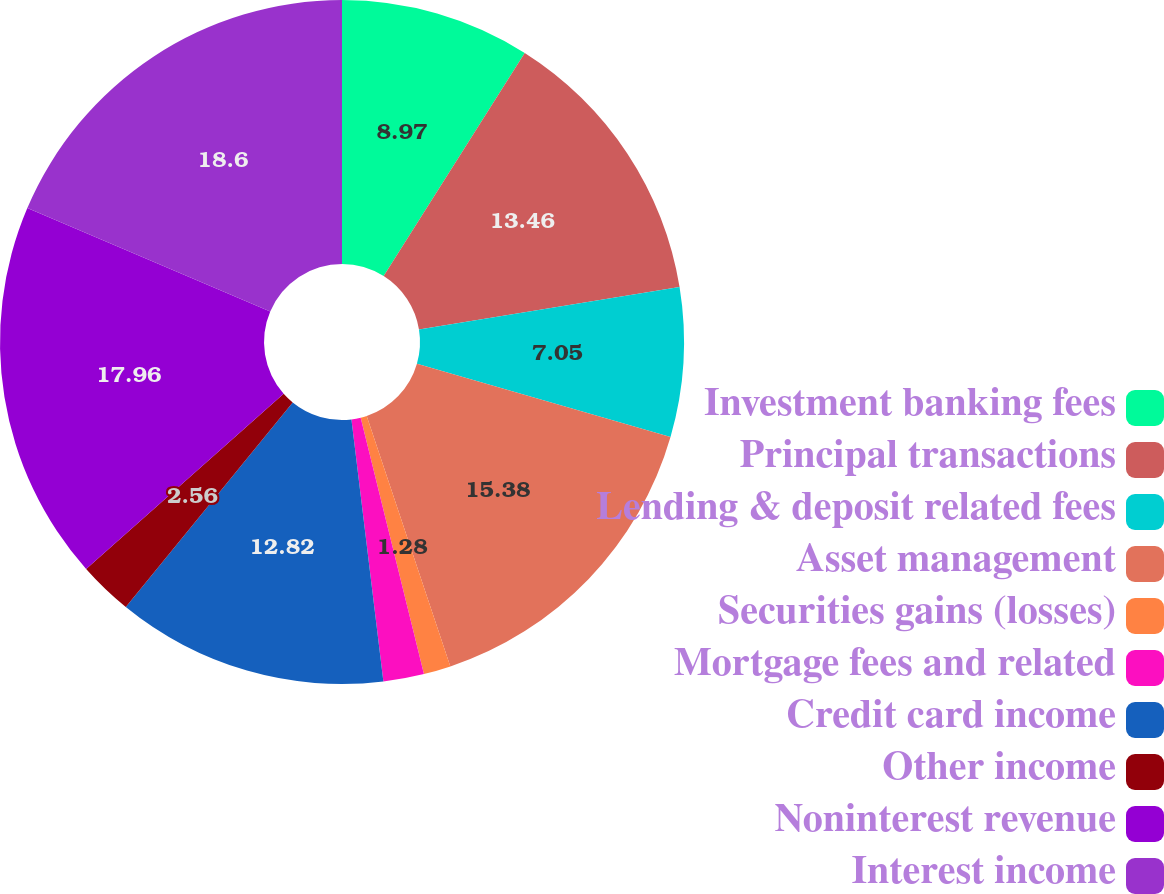Convert chart. <chart><loc_0><loc_0><loc_500><loc_500><pie_chart><fcel>Investment banking fees<fcel>Principal transactions<fcel>Lending & deposit related fees<fcel>Asset management<fcel>Securities gains (losses)<fcel>Mortgage fees and related<fcel>Credit card income<fcel>Other income<fcel>Noninterest revenue<fcel>Interest income<nl><fcel>8.97%<fcel>13.46%<fcel>7.05%<fcel>15.38%<fcel>1.28%<fcel>1.92%<fcel>12.82%<fcel>2.56%<fcel>17.95%<fcel>18.59%<nl></chart> 